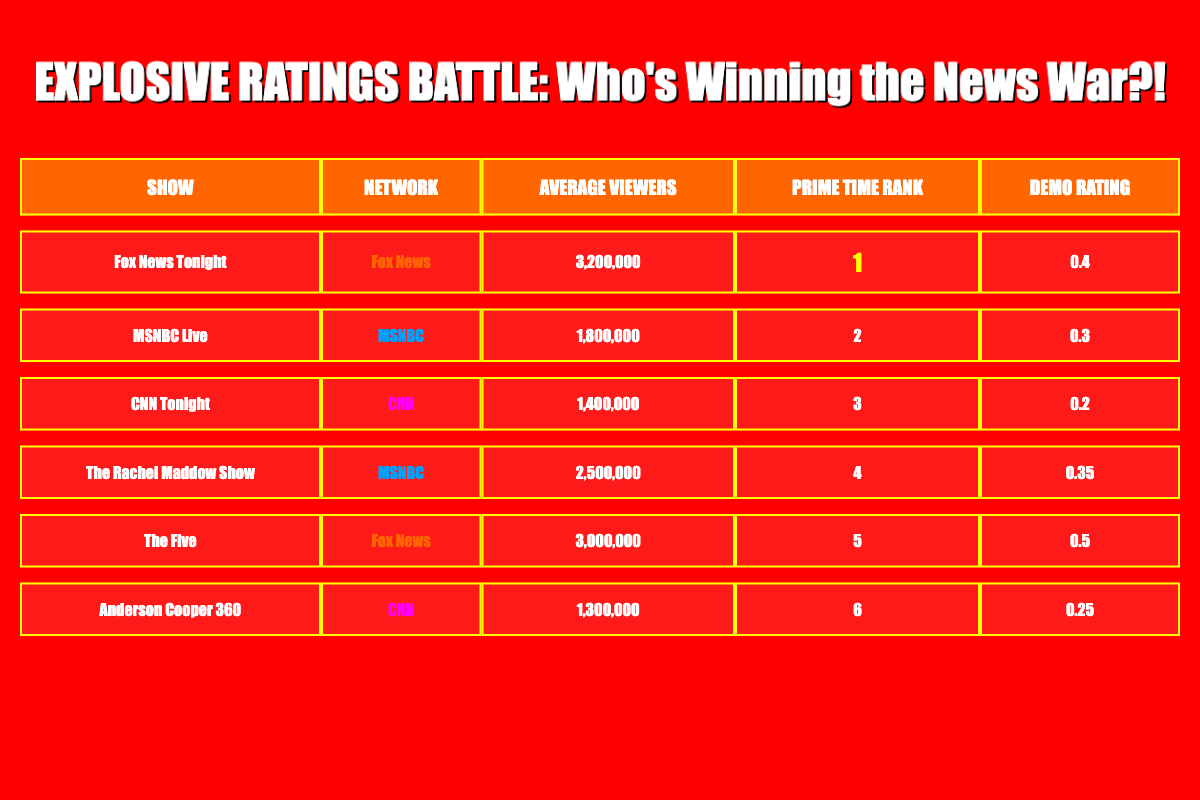What is the average viewership for Fox News Tonight? The table states that Fox News Tonight has an average viewership of 3,200,000. Therefore, the direct answer is simply that number.
Answer: 3,200,000 Which show ranks second in Prime Time? According to the table, MSNBC Live is listed with a Prime Time rank of 2. Thus, it is the answer to the question.
Answer: MSNBC Live Which network has shows in the top two ranks? The table shows that both Fox News Tonight (rank 1) and MSNBC Live (rank 2) are from different networks. Since Fox News is associated with rank 1 and MSNBC with rank 2, we identify both networks. To answer the question, we can simply state that Fox News and MSNBC have shows in the top two ranks.
Answer: Fox News and MSNBC What is the total average viewership of all CNN shows combined? CNN Tonight has 1,400,000 viewers, and Anderson Cooper 360 has 1,300,000 viewers. To find the total, we sum these two numbers: 1,400,000 + 1,300,000 = 2,700,000, which gives us the total average viewership for CNN shows.
Answer: 2,700,000 Is The Rachel Maddow Show more popular than CNN Tonight based on average viewers? The table shows that The Rachel Maddow Show has 2,500,000 average viewers, which is greater than CNN Tonight's 1,400,000 average viewers. Therefore, the statement is true.
Answer: Yes 